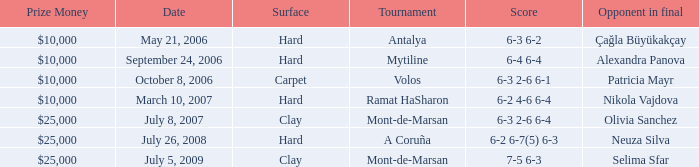Who was the opponent on carpet in a final? Patricia Mayr. 